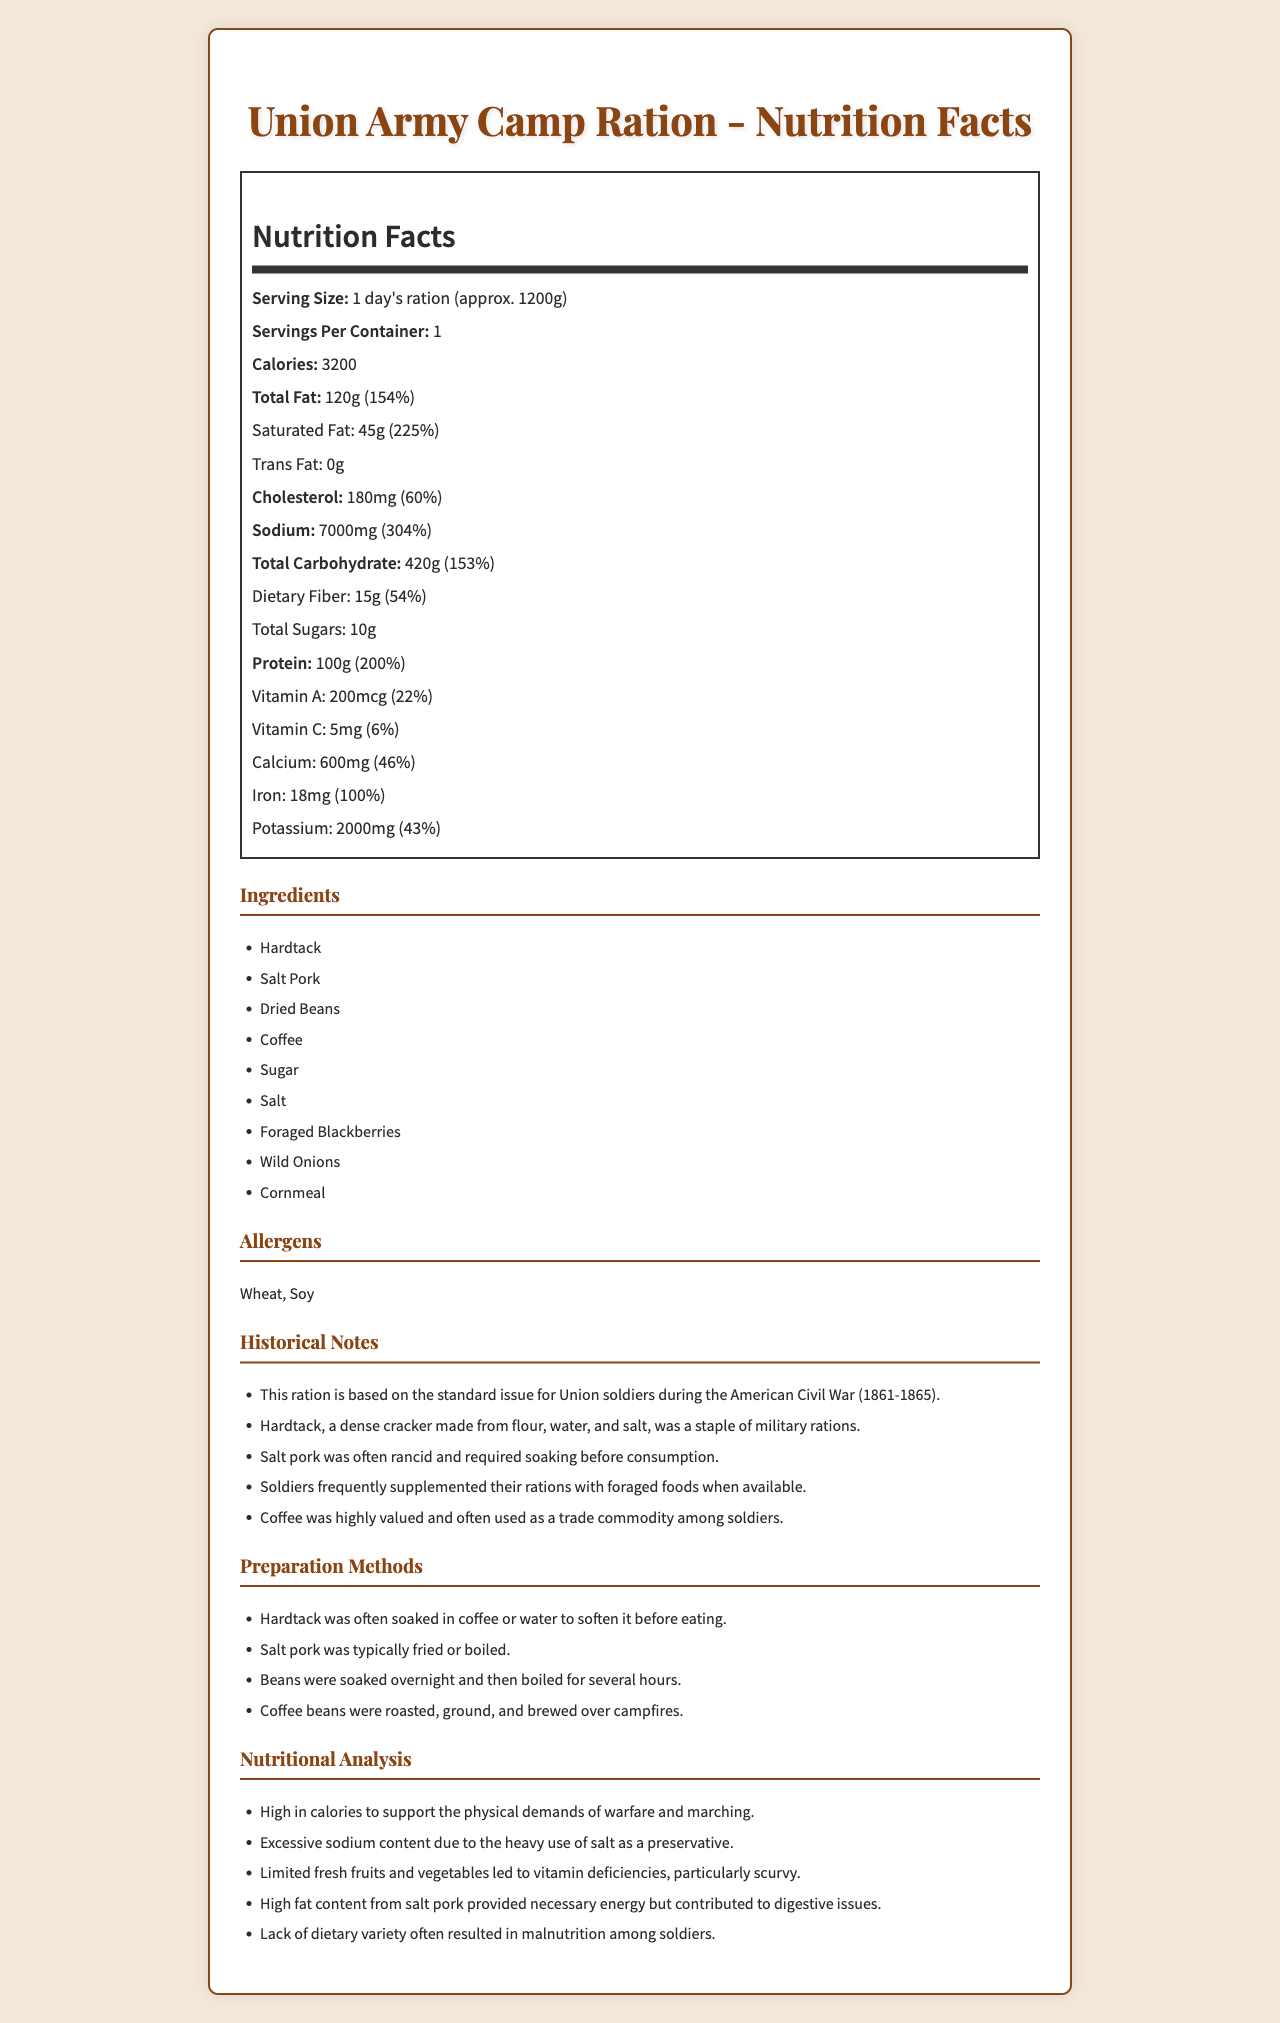what is the serving size of the Union Army Camp Ration? The serving size information is located in the Nutrition Facts section at the top of the document.
Answer: 1 day's ration (approx. 1200g) How many calories are in one serving of the Union Army Camp Ration? The calorie content is listed under the Nutrition Facts section, specifically noting the total calorie count.
Answer: 3200 Which ingredient in the Union Army Camp Ration is likely the main source of protein? Based on the ingredient list and common knowledge, dried beans are a significant source of protein.
Answer: Dried Beans What percentage of the Daily Value of sodium does one serving contain? The sodium content and its Daily Value percentage are listed in the Nutrition Facts section.
Answer: 304% What preparation method is used for hardtack? A. Soaked in coffee or water B. Fried or boiled C. Roasted, ground, and brewed D. Soaked overnight and then boiled The preparation methods section lists that hardtack was often soaked in coffee or water.
Answer: A What were some of the nutritional challenges faced by Union soldiers? (Select all that apply) I. Vitamin deficiencies II. Excessive protein intake III. High sodium content IV. Lack of dietary variety The nutritional analysis section notes vitamin deficiencies, high sodium content, and lack of dietary variety as significant issues.
Answer: I, III, IV Is it true that coffee beans were roasted, ground, and brewed over campfires? The preparation methods section confirms that coffee beans were treated in this way.
Answer: Yes Summarize the main nutritional characteristics of the Union Army Camp Ration. This summary encapsulates the key nutritional characteristics and the nutritional analysis of the Union Army Camp Ration described in the document.
Answer: The Union Army Camp Ration provided high calories and protein but suffered from excessive sodium and fat content. There was limited dietary variety, leading to common issues like vitamin deficiencies and malnutrition among soldiers. How many vitamins and minerals are listed with their amounts and Daily Values? The document lists Vitamin A, Vitamin C, Calcium, Iron, and Potassium with their respective amounts and Daily Value percentages.
Answer: Five What is the main source of carbohydrates in the Union Army Camp Ration? The main sources of carbohydrates, based on the ingredient list, are hardtack and cornmeal.
Answer: Hardtack and Cornmeal What historical period does this ration reflect? The historical notes section specifies that this ration is based on the standard issue for Union soldiers during the American Civil War (1861-1865).
Answer: American Civil War (1861-1865) How much cholesterol does the Union Army Camp Ration contain? The cholesterol content is listed in the Nutrition Facts section of the document.
Answer: 180 mg Was sugar included in the Union Army Camp Ration? If yes, how much? The document indicates that total sugars amount to 10g per serving in the Nutrition Facts section.
Answer: Yes, 10g How would a soldier likely prepare beans in the camp? The preparation methods section describes how beans were prepared by soaking overnight and then boiling for several hours.
Answer: Soaked overnight and then boiled for several hours What total amount of fat is present in one day's ration of the Union Army Camp Ration? The total fat amount is listed under the Nutrition Facts section.
Answer: 120g What is the historical significance of coffee in the Union Army Camp Ration? This significant detail is mentioned in the historical notes section.
Answer: Coffee was highly valued and often used as a trade commodity among soldiers. What was often the state of salt pork included in the rations? The historical notes section indicates the poor state of salt pork, requiring soaking before eating.
Answer: Often rancid and required soaking before consumption Why was sodium content so high in these rations? The detailed sodium content and high percentage of daily value reflect its preservation role mentioned in the nutritional analysis.
Answer: Due to the heavy use of salt as a preservative. What modern-day allergens are listed for these camp rations? The allergens section specifies wheat and soy as the listed allergens.
Answer: Wheat, Soy How much Vitamin C is provided in one serving of the Union Army Camp Ration? The Vitamin C content is part of the Nutrition Facts given in the document.
Answer: 5mg What is the serving size of the Confederate Army Camp Ration? The document provides details only about the Union Army Camp Ration.
Answer: Cannot be determined 